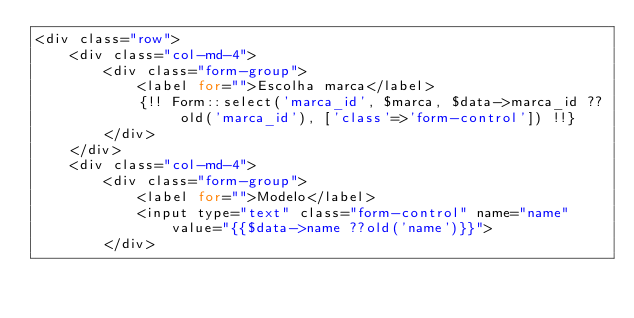Convert code to text. <code><loc_0><loc_0><loc_500><loc_500><_PHP_><div class="row">
    <div class="col-md-4">
        <div class="form-group">
            <label for="">Escolha marca</label>
            {!! Form::select('marca_id', $marca, $data->marca_id ?? old('marca_id'), ['class'=>'form-control']) !!}
        </div>
    </div>
    <div class="col-md-4">
        <div class="form-group">
            <label for="">Modelo</label>
            <input type="text" class="form-control" name="name" value="{{$data->name ??old('name')}}">
        </div></code> 